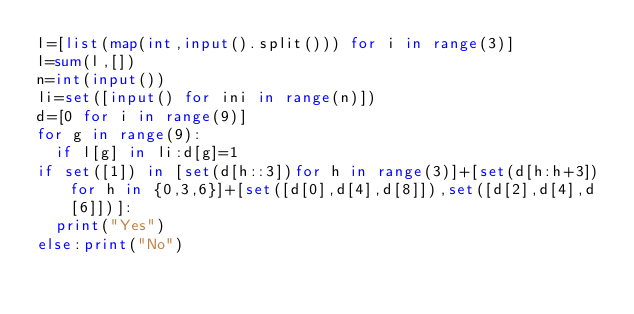Convert code to text. <code><loc_0><loc_0><loc_500><loc_500><_Python_>l=[list(map(int,input().split())) for i in range(3)]
l=sum(l,[])
n=int(input())
li=set([input() for ini in range(n)])
d=[0 for i in range(9)]
for g in range(9):
  if l[g] in li:d[g]=1
if set([1]) in [set(d[h::3])for h in range(3)]+[set(d[h:h+3])for h in {0,3,6}]+[set([d[0],d[4],d[8]]),set([d[2],d[4],d[6]])]:
  print("Yes")
else:print("No")
</code> 